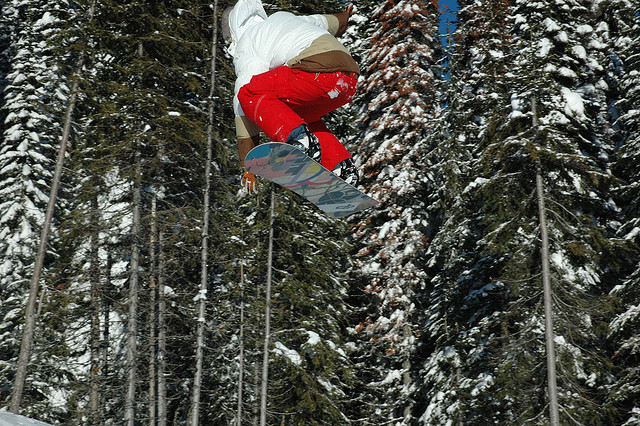<image>What is the type of street art that the snowboard design looks like? I am not sure about the exact type of street art the snowboard design looks like. It can be seen like graffiti or abstract art. What is the type of street art that the snowboard design looks like? I am not sure what is the type of street art that the snowboard design looks like. But it can be seen as graffiti. 